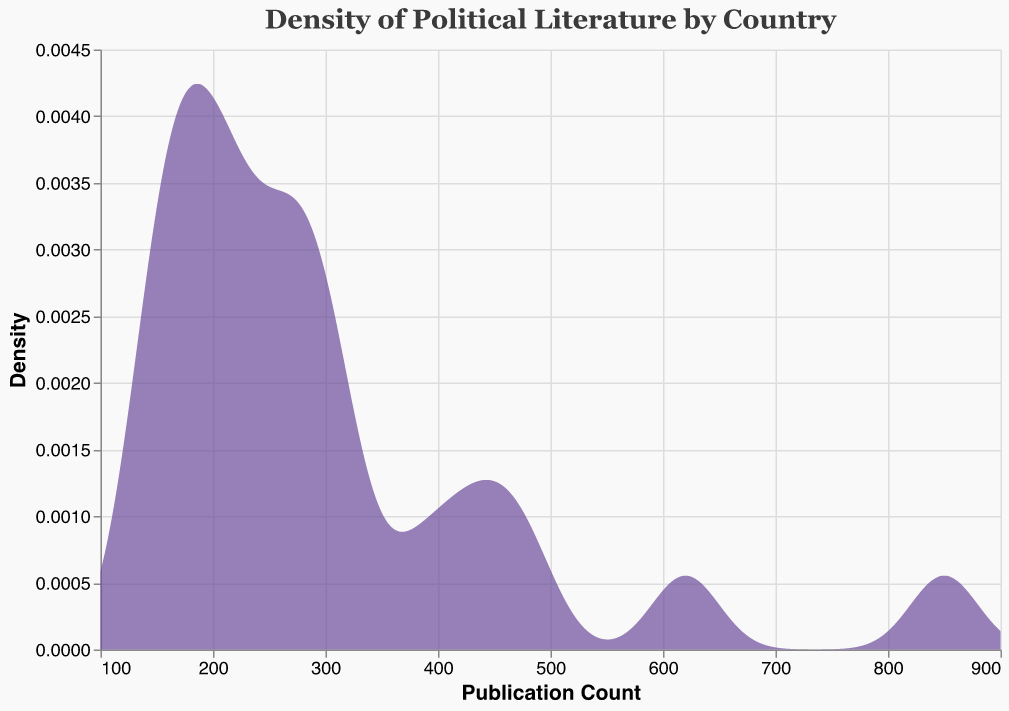what is the title of the density plot? The title of the density plot is presented at the top of the figure. It reads "Density of Political Literature by Country" and is styled with a specific font and color.
Answer: Density of Political Literature by Country What is the color of the area in the density plot? The color of the area representing the density in the plot is a shade of purple.
Answer: Purple Which country has the highest publication count? To find which country has the highest publication count, look for the peak on the x-axis that is furthest to the right. The highest publication count is from the United States with 850 publications.
Answer: United States What is the bandwidth used for the density estimation? The bandwidth used for the density estimation is indicated in the description of the figure data. The bandwidth is 30.
Answer: 30 At what publication count does the density plot begin? The density plot begins at a publication count of 100, as indicated by the x-axis.
Answer: 100 Given the data, what is the range in publication counts presented in the plot? The publication counts range from a minimum of 140 to a maximum of 850.
Answer: 140 to 850 How many countries have a publication count greater than 400? To find the number of countries with publication counts greater than 400, we need to check each country’s publication count: United States, United Kingdom, Germany, France, and China. There are five such countries.
Answer: 5 What publication count corresponds to the highest density on the plot? The plot's highest density corresponds to the publication counts where the peaks occur. The exact publication count for the highest density can't be determined without seeing the precise peak, but it will be near the middle of dense data points around 300-400 publication counts.
Answer: Approx. 300-400 Compare the publication counts of United States and United Kingdom. Which country has more and by how much? The United States has 850 publications, while the United Kingdom has 620 publications. Subtracting these gives the difference: 850 - 620 = 230. Therefore, the United States has 230 more publications than the United Kingdom.
Answer: 230 What does the y-axis represent in the plot? The y-axis represents the density of political literature publication counts. Density is a measure of the number of publications.
Answer: Density 